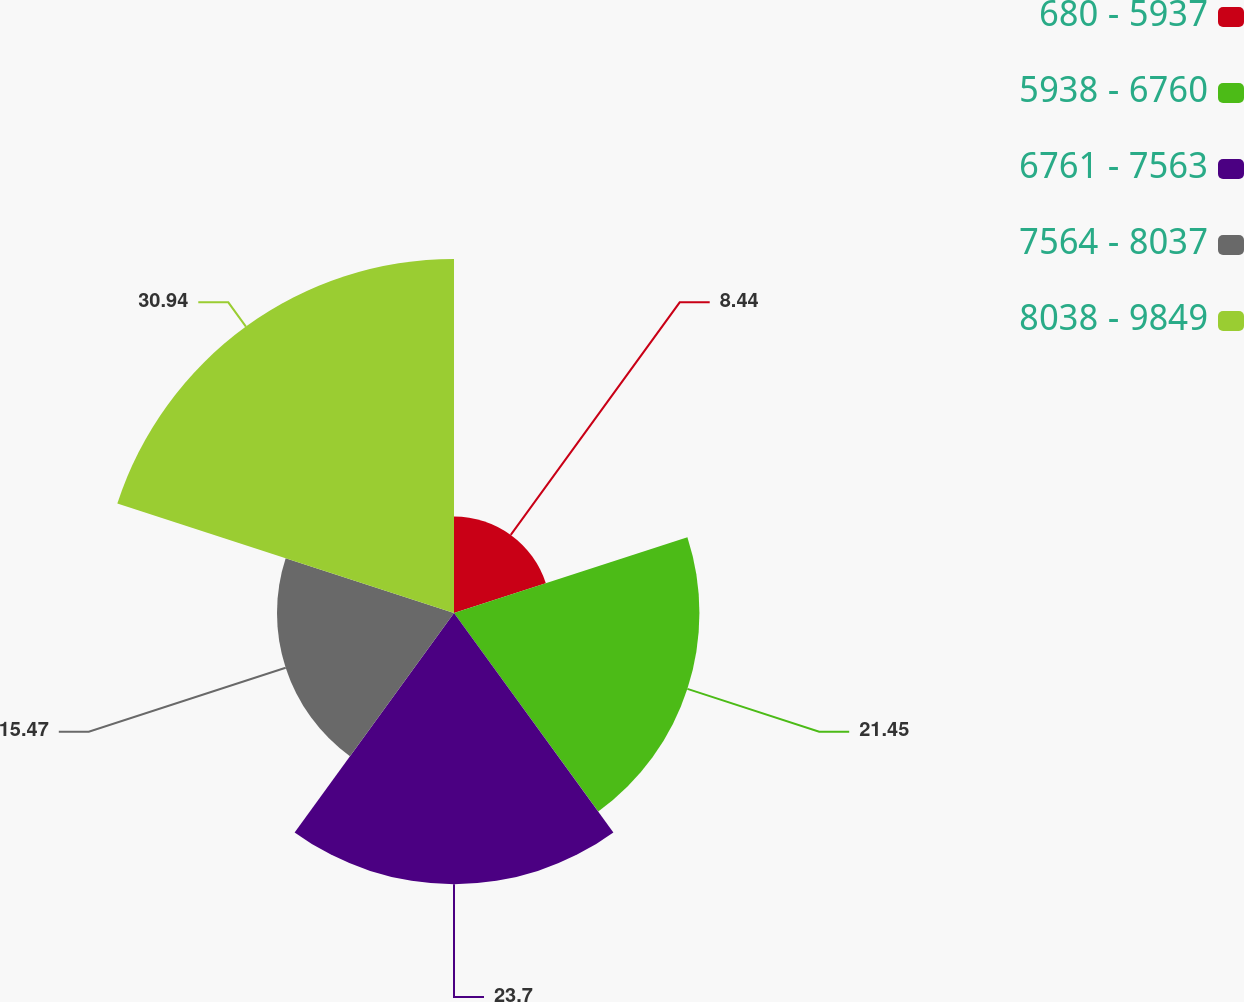Convert chart. <chart><loc_0><loc_0><loc_500><loc_500><pie_chart><fcel>680 - 5937<fcel>5938 - 6760<fcel>6761 - 7563<fcel>7564 - 8037<fcel>8038 - 9849<nl><fcel>8.44%<fcel>21.45%<fcel>23.7%<fcel>15.47%<fcel>30.94%<nl></chart> 